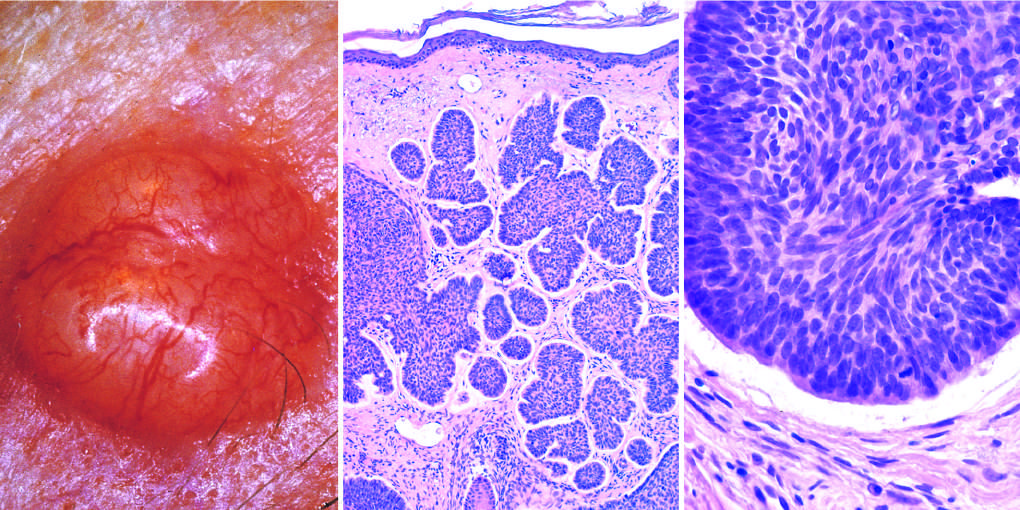what is the cleft between the tumor cells and the stroma?
Answer the question using a single word or phrase. A highly characteristic artifact of sectioning 